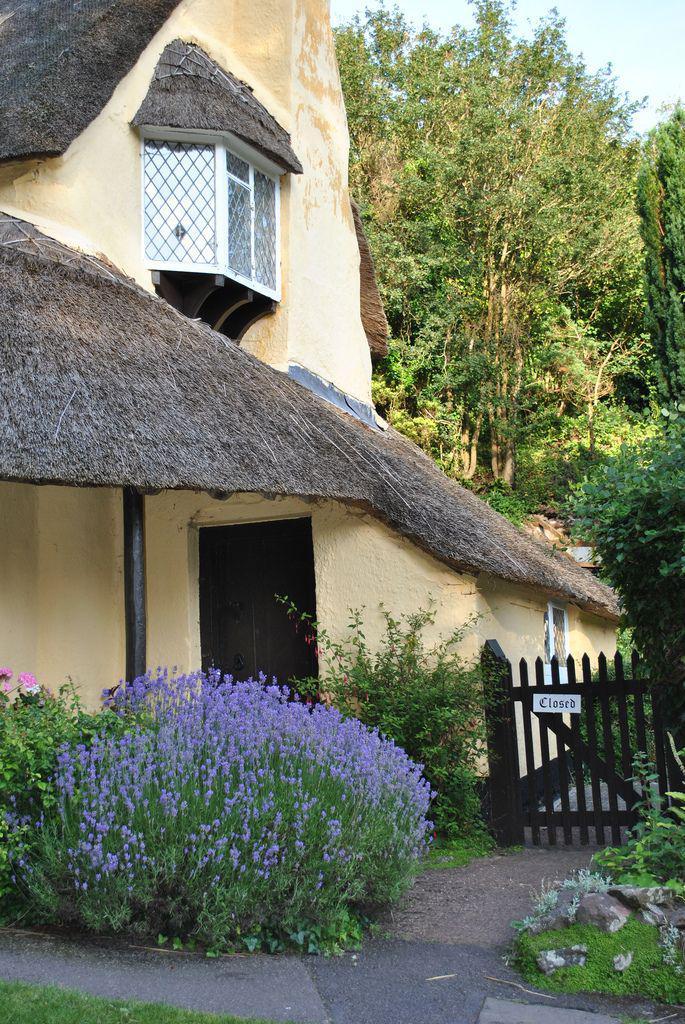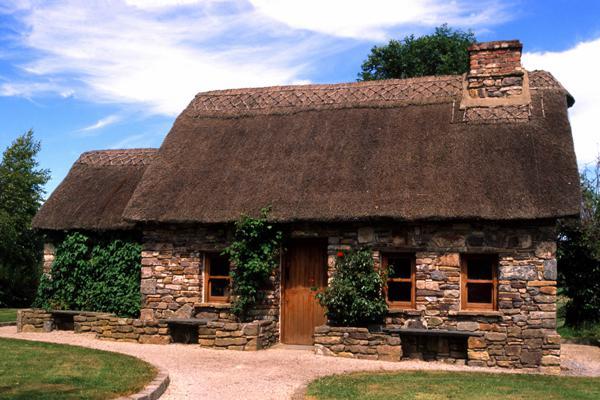The first image is the image on the left, the second image is the image on the right. Evaluate the accuracy of this statement regarding the images: "there is a home with a thatch roof, fencing and flowers are next to the home". Is it true? Answer yes or no. Yes. 